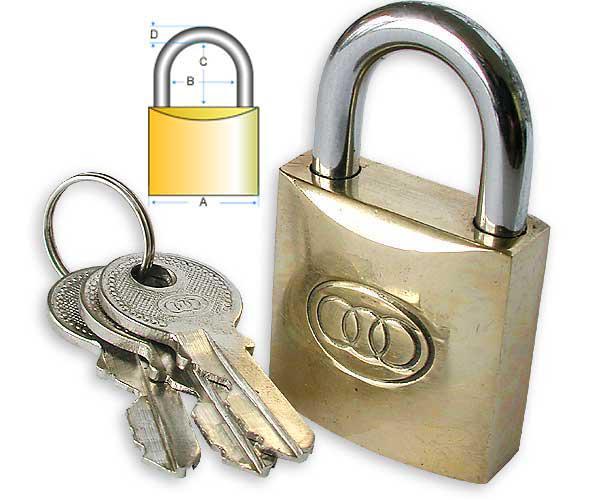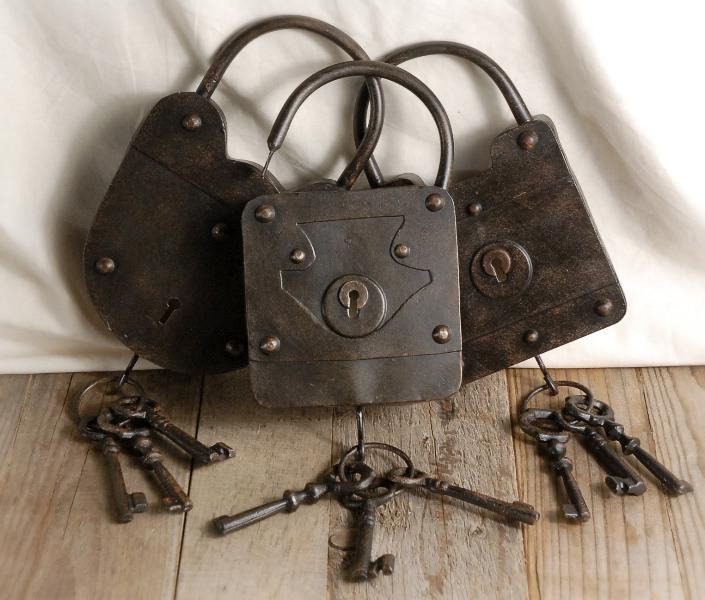The first image is the image on the left, the second image is the image on the right. Given the left and right images, does the statement "One image shows three antique padlocks with keyholes visible on the lower front panel of the padlock, with keys displayed in front of them." hold true? Answer yes or no. Yes. The first image is the image on the left, the second image is the image on the right. For the images shown, is this caption "There are three padlocks in total." true? Answer yes or no. No. 